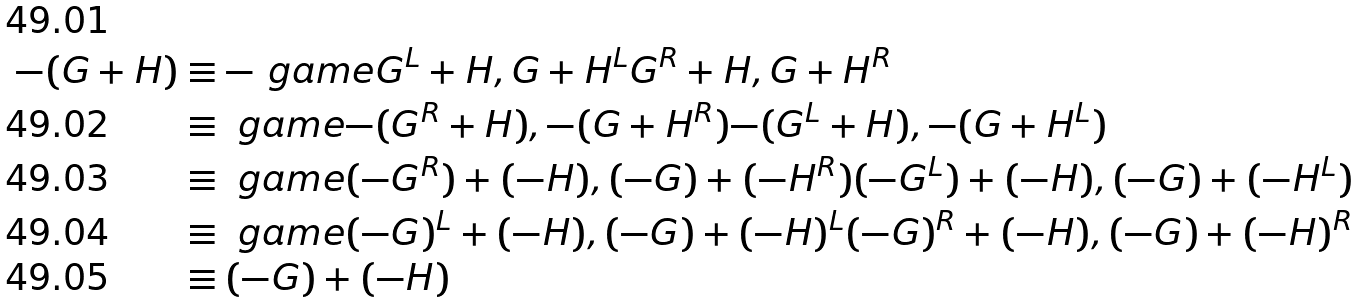Convert formula to latex. <formula><loc_0><loc_0><loc_500><loc_500>- ( G + H ) & \equiv - \ g a m e { G ^ { L } + H , G + H ^ { L } } { G ^ { R } + H , G + H ^ { R } } \\ & \equiv \ g a m e { - ( G ^ { R } + H ) , - ( G + H ^ { R } ) } { - ( G ^ { L } + H ) , - ( G + H ^ { L } ) } \\ & \equiv \ g a m e { ( - G ^ { R } ) + ( - H ) , ( - G ) + ( - H ^ { R } ) } { ( - G ^ { L } ) + ( - H ) , ( - G ) + ( - H ^ { L } ) } \\ & \equiv \ g a m e { ( - G ) ^ { L } + ( - H ) , ( - G ) + ( - H ) ^ { L } } { ( - G ) ^ { R } + ( - H ) , ( - G ) + ( - H ) ^ { R } } \\ & \equiv ( - G ) + ( - H )</formula> 